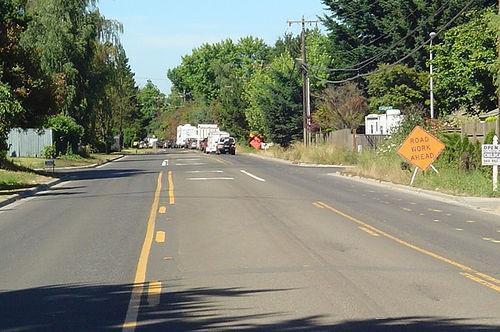How many people are wearing a hat?
Give a very brief answer. 0. 